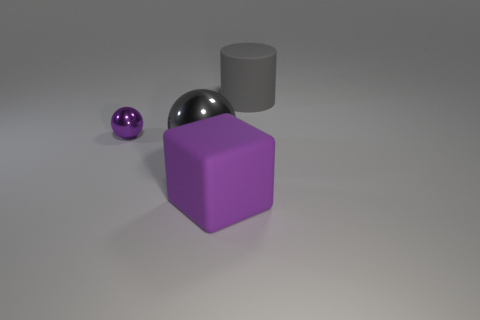Is there another purple ball of the same size as the purple metallic sphere? no 